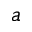Convert formula to latex. <formula><loc_0><loc_0><loc_500><loc_500>a</formula> 